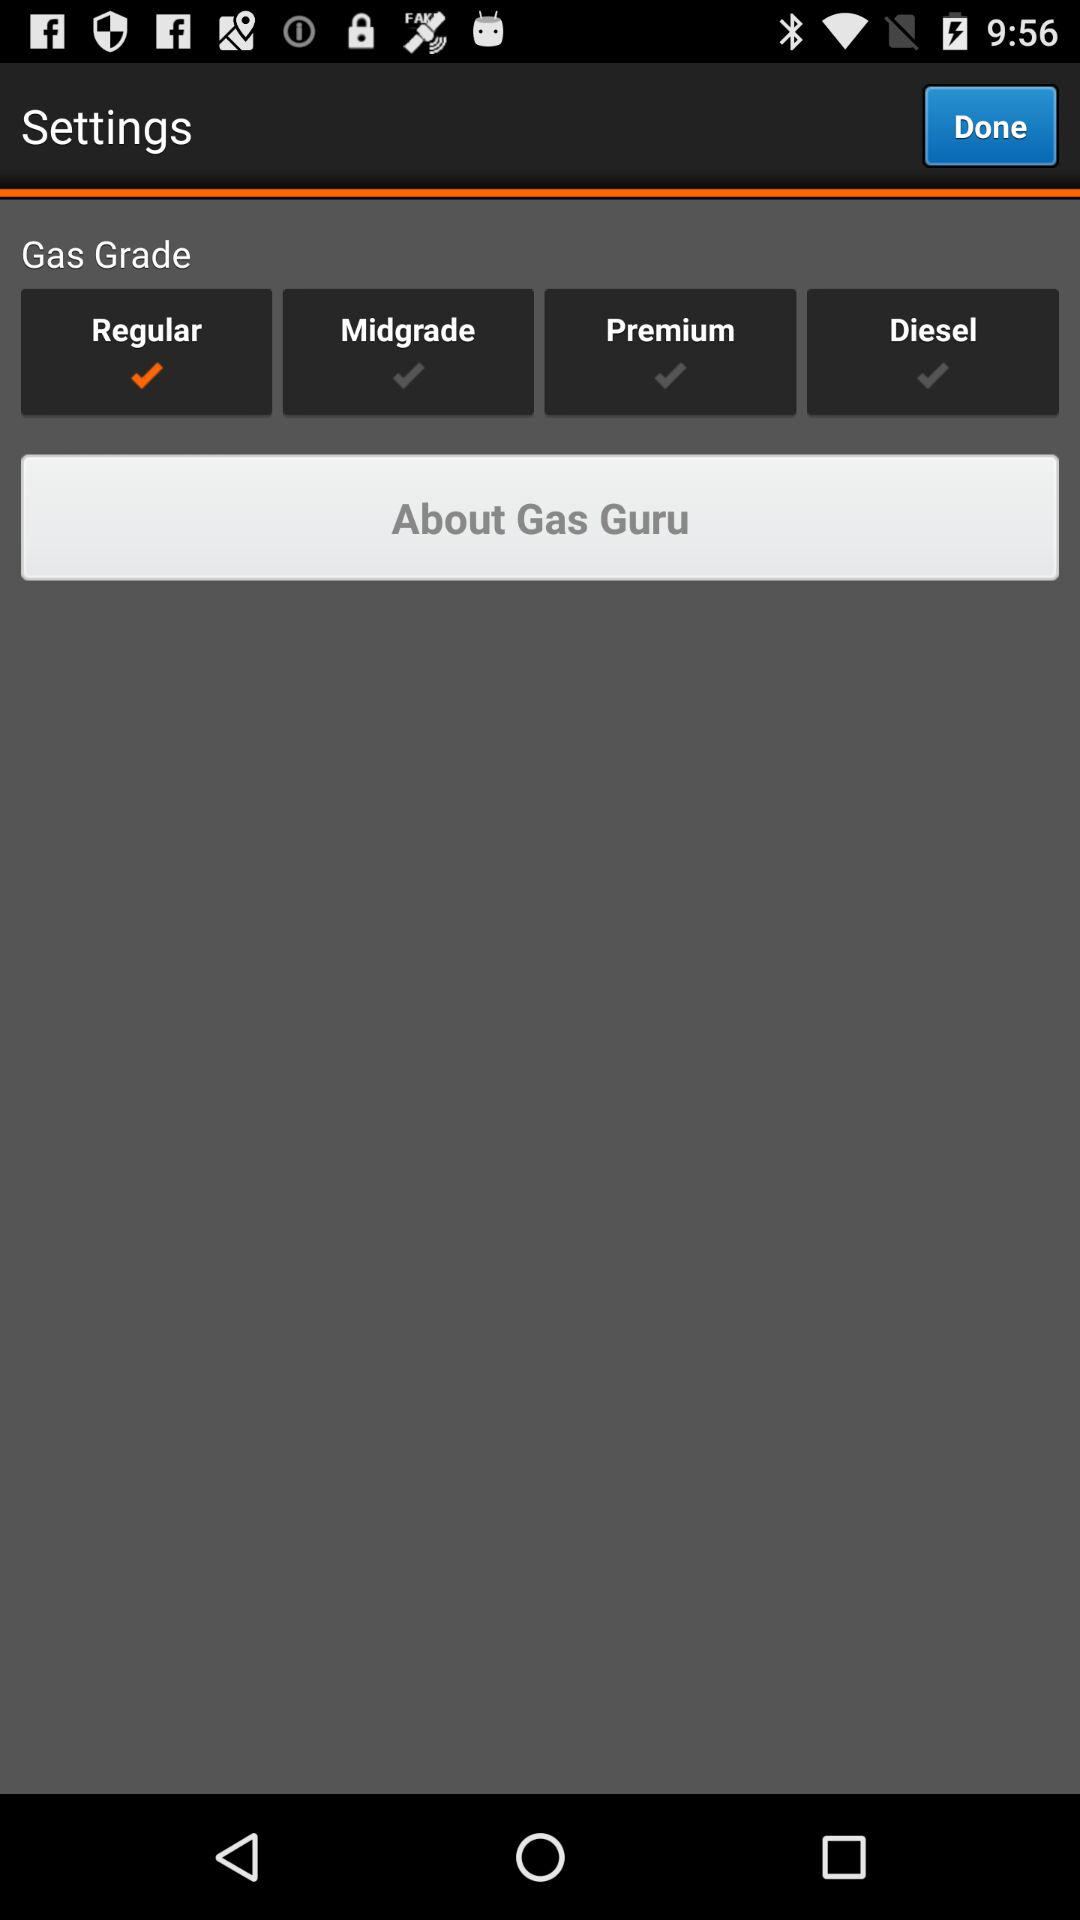Which version of "Gas Guru" is this?
When the provided information is insufficient, respond with <no answer>. <no answer> 